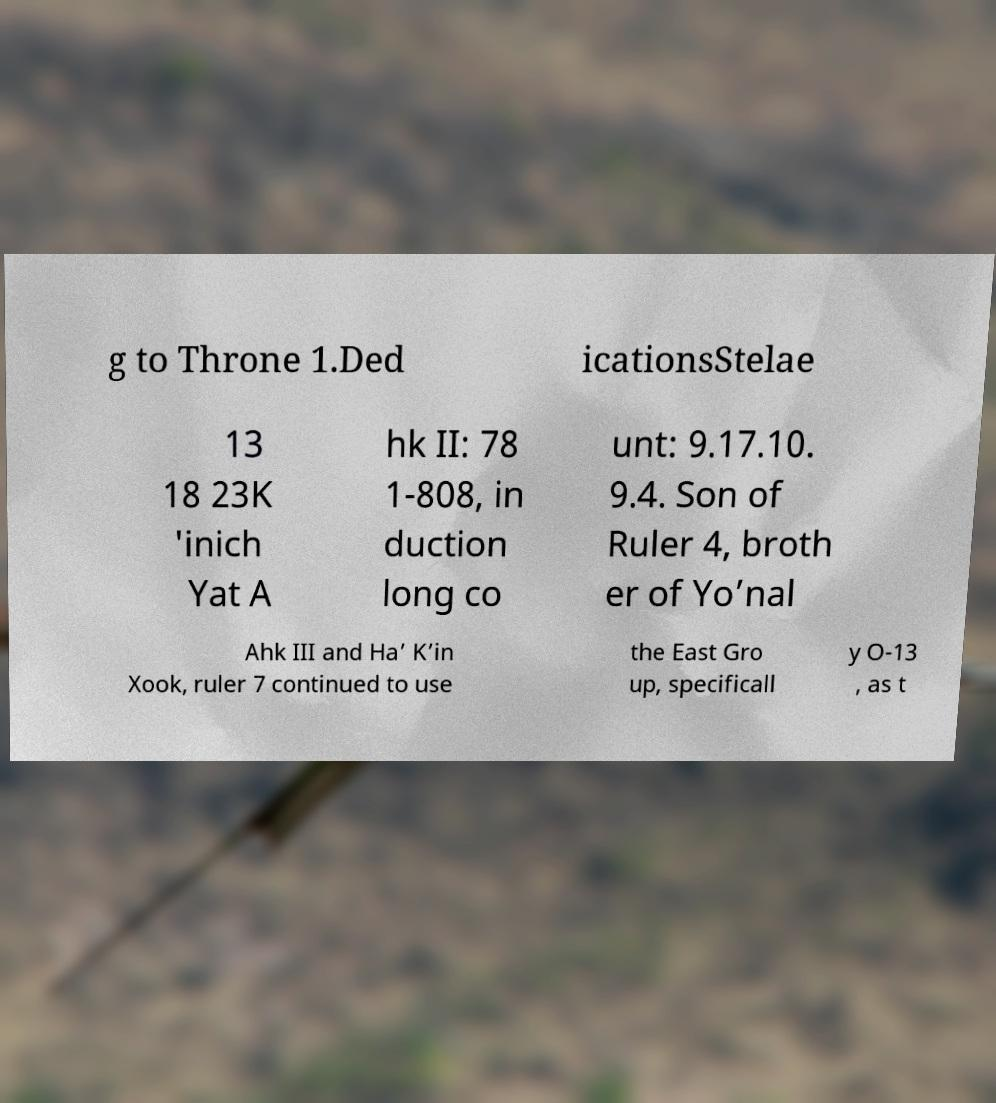Can you accurately transcribe the text from the provided image for me? g to Throne 1.Ded icationsStelae 13 18 23K 'inich Yat A hk II: 78 1-808, in duction long co unt: 9.17.10. 9.4. Son of Ruler 4, broth er of Yo’nal Ahk III and Ha’ K’in Xook, ruler 7 continued to use the East Gro up, specificall y O-13 , as t 